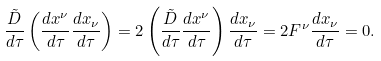Convert formula to latex. <formula><loc_0><loc_0><loc_500><loc_500>\frac { \tilde { D } } { d \tau } \left ( \frac { d x ^ { \nu } } { d \tau } \frac { d x _ { \nu } } { d \tau } \right ) = 2 \left ( \frac { \tilde { D } } { d \tau } \frac { d x ^ { \nu } } { d \tau } \right ) \frac { d x _ { \nu } } { d \tau } = 2 F ^ { \nu } \frac { d x _ { \nu } } { d \tau } = 0 .</formula> 